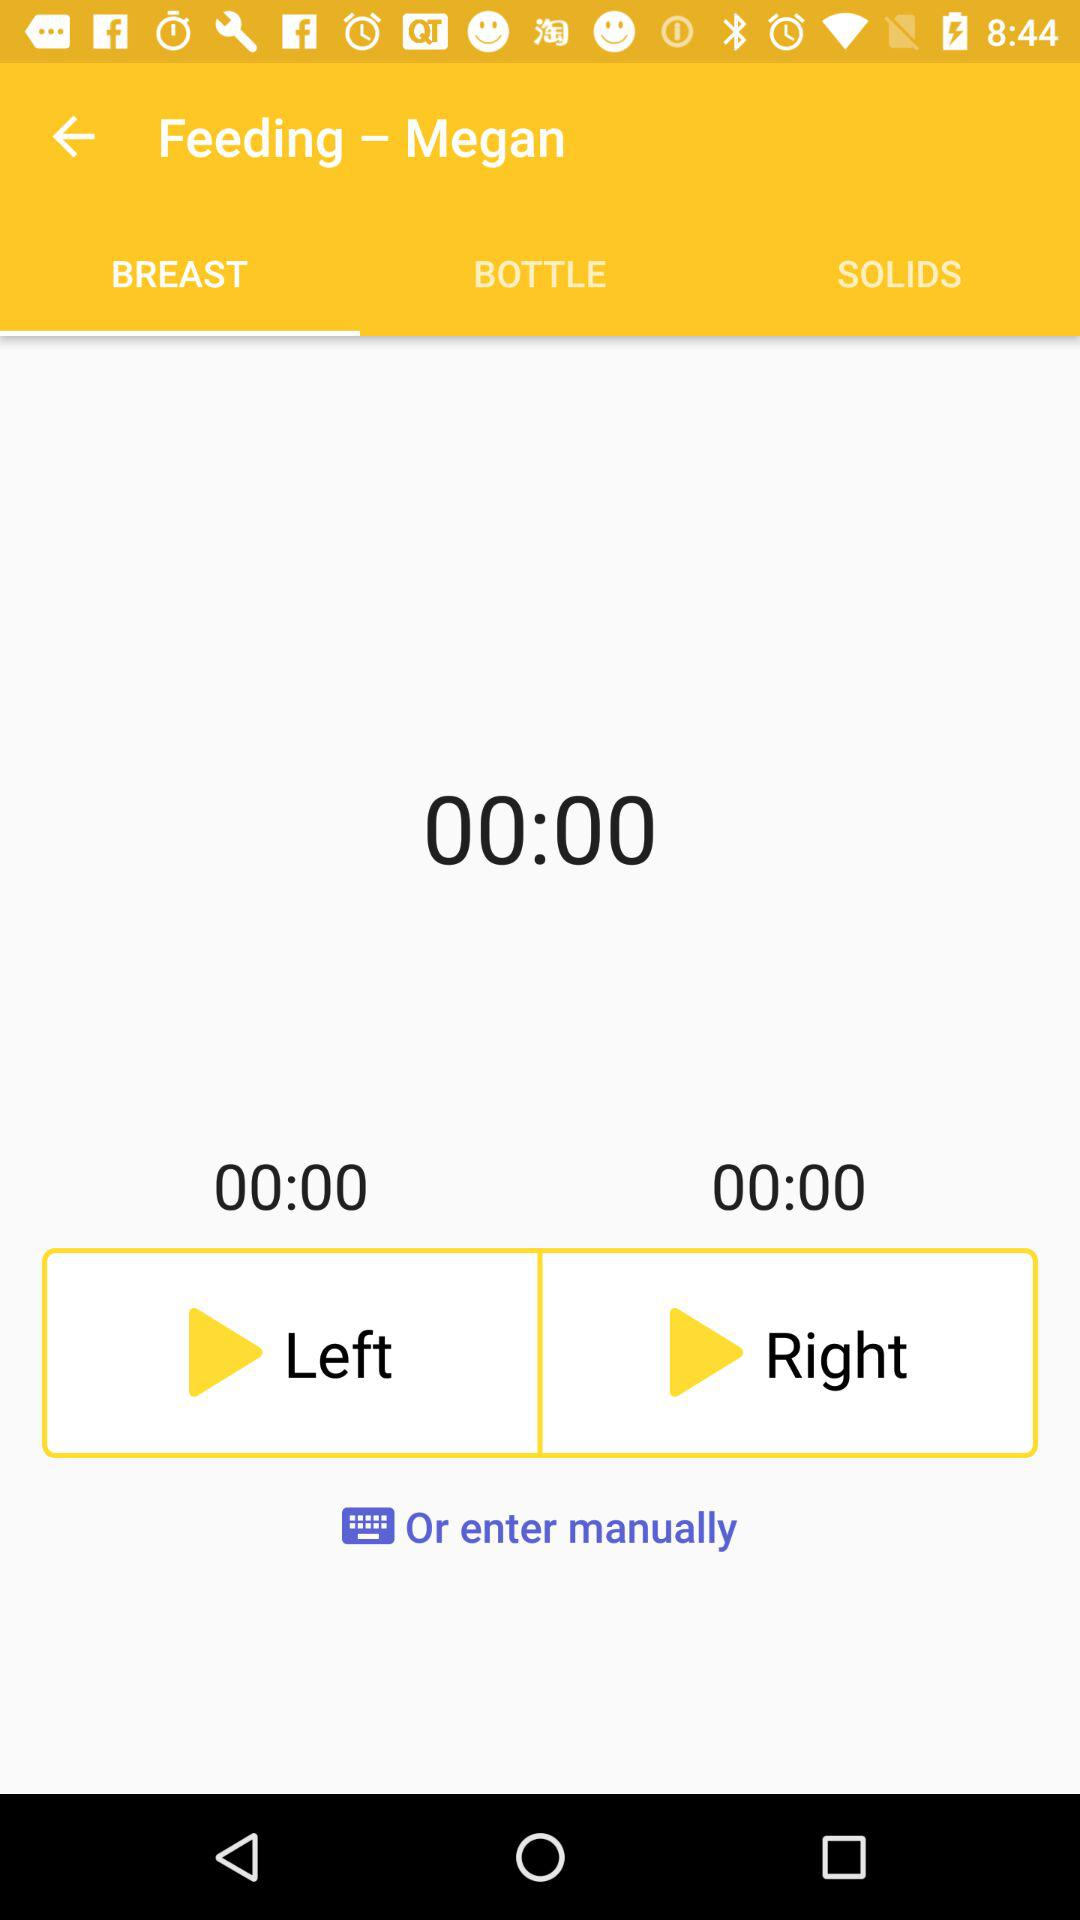What is the total duration of breastfeeding? The total duration of breastfeeding is 00:00. 